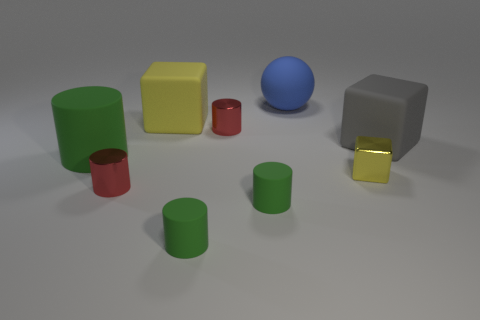Is there any other thing that is the same size as the metal cube?
Give a very brief answer. Yes. There is a large block that is the same color as the tiny block; what material is it?
Make the answer very short. Rubber. What size is the other matte block that is the same color as the small cube?
Give a very brief answer. Large. What number of big rubber objects are the same color as the tiny metal block?
Your response must be concise. 1. Are there any other spheres of the same size as the blue rubber ball?
Ensure brevity in your answer.  No. How many objects are either cylinders in front of the tiny cube or gray spheres?
Provide a short and direct response. 3. Does the tiny yellow block have the same material as the yellow cube that is to the left of the big blue ball?
Offer a terse response. No. What number of other things are there of the same shape as the gray matte thing?
Offer a very short reply. 2. How many objects are either rubber things behind the large gray matte block or small cylinders that are to the right of the big cylinder?
Your answer should be very brief. 6. How many other things are the same color as the matte sphere?
Ensure brevity in your answer.  0. 